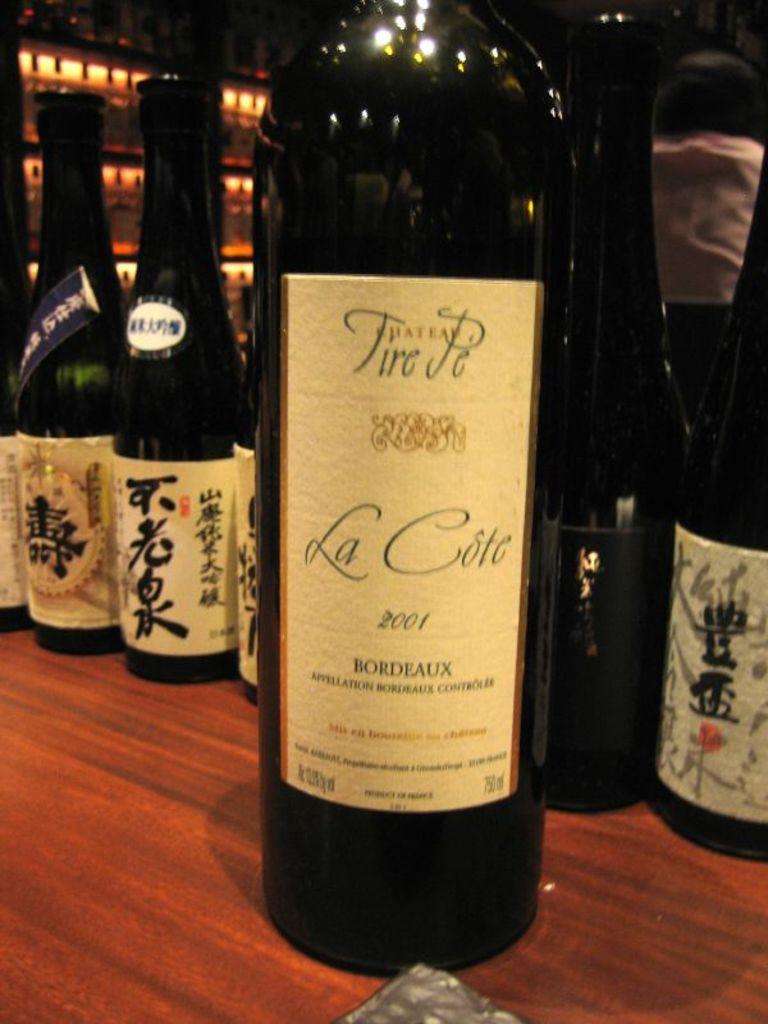What year was it bottled?
Make the answer very short. 2001. 